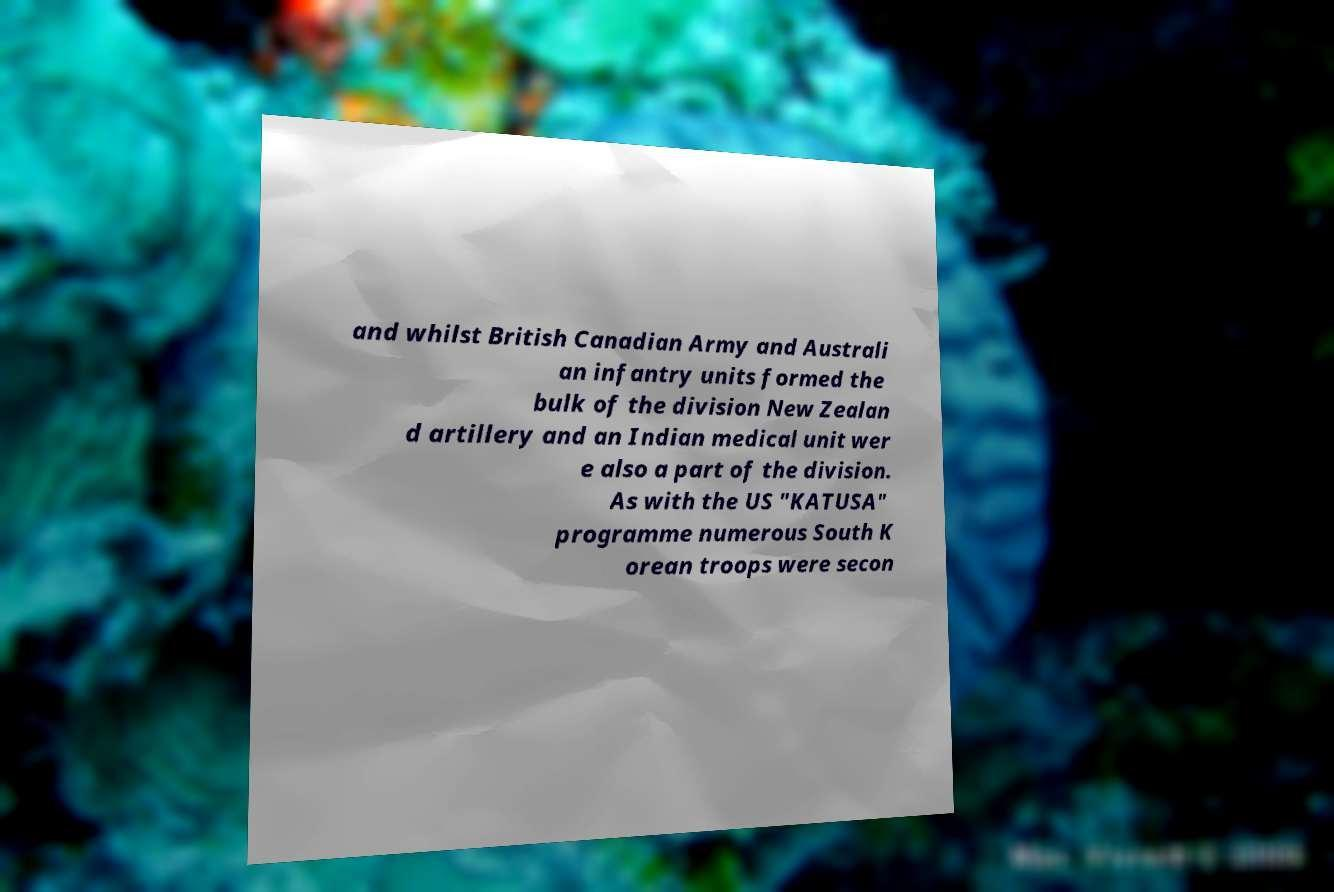Please identify and transcribe the text found in this image. and whilst British Canadian Army and Australi an infantry units formed the bulk of the division New Zealan d artillery and an Indian medical unit wer e also a part of the division. As with the US "KATUSA" programme numerous South K orean troops were secon 